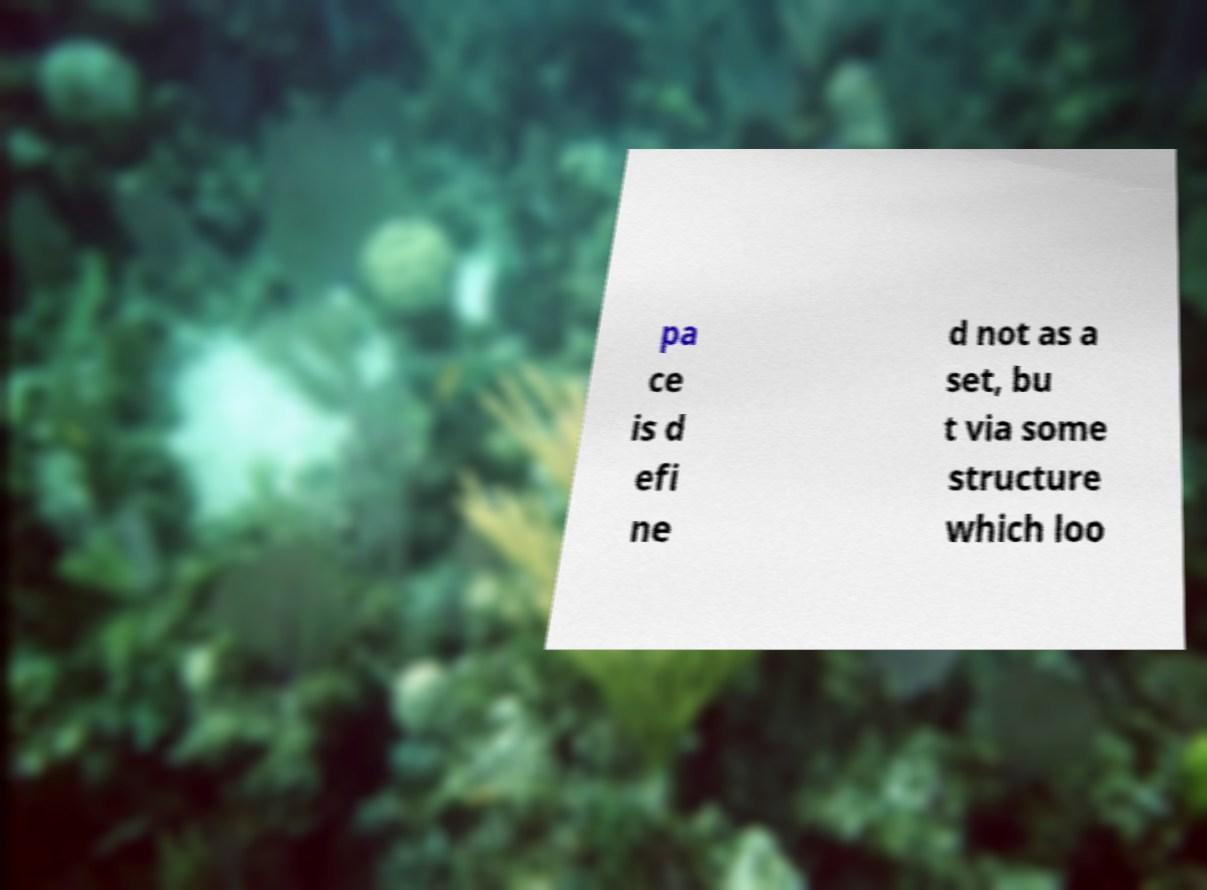Please identify and transcribe the text found in this image. pa ce is d efi ne d not as a set, bu t via some structure which loo 